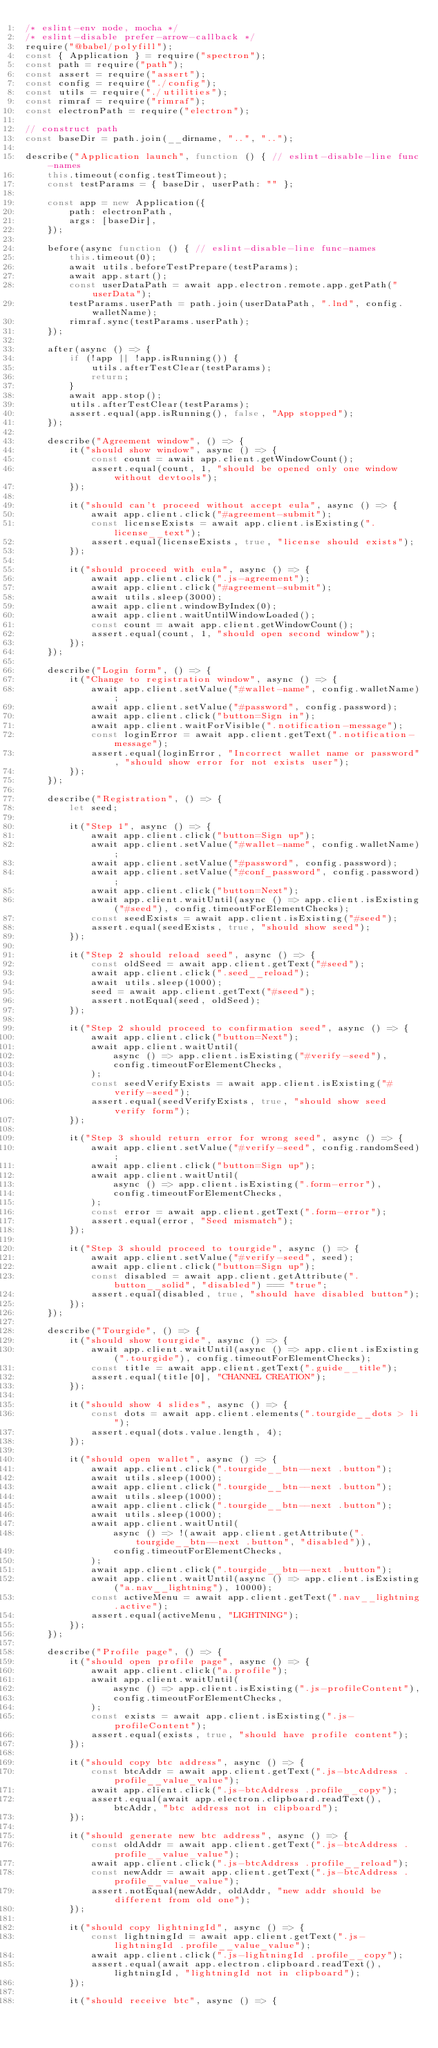<code> <loc_0><loc_0><loc_500><loc_500><_JavaScript_>/* eslint-env node, mocha */
/* eslint-disable prefer-arrow-callback */
require("@babel/polyfill");
const { Application } = require("spectron");
const path = require("path");
const assert = require("assert");
const config = require("./config");
const utils = require("./utilities");
const rimraf = require("rimraf");
const electronPath = require("electron");

// construct path
const baseDir = path.join(__dirname, "..", "..");

describe("Application launch", function () { // eslint-disable-line func-names
    this.timeout(config.testTimeout);
    const testParams = { baseDir, userPath: "" };

    const app = new Application({
        path: electronPath,
        args: [baseDir],
    });

    before(async function () { // eslint-disable-line func-names
        this.timeout(0);
        await utils.beforeTestPrepare(testParams);
        await app.start();
        const userDataPath = await app.electron.remote.app.getPath("userData");
        testParams.userPath = path.join(userDataPath, ".lnd", config.walletName);
        rimraf.sync(testParams.userPath);
    });

    after(async () => {
        if (!app || !app.isRunning()) {
            utils.afterTestClear(testParams);
            return;
        }
        await app.stop();
        utils.afterTestClear(testParams);
        assert.equal(app.isRunning(), false, "App stopped");
    });

    describe("Agreement window", () => {
        it("should show window", async () => {
            const count = await app.client.getWindowCount();
            assert.equal(count, 1, "should be opened only one window without devtools");
        });

        it("should can't proceed without accept eula", async () => {
            await app.client.click("#agreement-submit");
            const licenseExists = await app.client.isExisting(".license__text");
            assert.equal(licenseExists, true, "license should exists");
        });

        it("should proceed with eula", async () => {
            await app.client.click(".js-agreement");
            await app.client.click("#agreement-submit");
            await utils.sleep(3000);
            await app.client.windowByIndex(0);
            await app.client.waitUntilWindowLoaded();
            const count = await app.client.getWindowCount();
            assert.equal(count, 1, "should open second window");
        });
    });

    describe("Login form", () => {
        it("Change to registration window", async () => {
            await app.client.setValue("#wallet-name", config.walletName);
            await app.client.setValue("#password", config.password);
            await app.client.click("button=Sign in");
            await app.client.waitForVisible(".notification-message");
            const loginError = await app.client.getText(".notification-message");
            assert.equal(loginError, "Incorrect wallet name or password", "should show error for not exists user");
        });
    });

    describe("Registration", () => {
        let seed;

        it("Step 1", async () => {
            await app.client.click("button=Sign up");
            await app.client.setValue("#wallet-name", config.walletName);
            await app.client.setValue("#password", config.password);
            await app.client.setValue("#conf_password", config.password);
            await app.client.click("button=Next");
            await app.client.waitUntil(async () => app.client.isExisting("#seed"), config.timeoutForElementChecks);
            const seedExists = await app.client.isExisting("#seed");
            assert.equal(seedExists, true, "should show seed");
        });

        it("Step 2 should reload seed", async () => {
            const oldSeed = await app.client.getText("#seed");
            await app.client.click(".seed__reload");
            await utils.sleep(1000);
            seed = await app.client.getText("#seed");
            assert.notEqual(seed, oldSeed);
        });

        it("Step 2 should proceed to confirmation seed", async () => {
            await app.client.click("button=Next");
            await app.client.waitUntil(
                async () => app.client.isExisting("#verify-seed"),
                config.timeoutForElementChecks,
            );
            const seedVerifyExists = await app.client.isExisting("#verify-seed");
            assert.equal(seedVerifyExists, true, "should show seed verify form");
        });

        it("Step 3 should return error for wrong seed", async () => {
            await app.client.setValue("#verify-seed", config.randomSeed);
            await app.client.click("button=Sign up");
            await app.client.waitUntil(
                async () => app.client.isExisting(".form-error"),
                config.timeoutForElementChecks,
            );
            const error = await app.client.getText(".form-error");
            assert.equal(error, "Seed mismatch");
        });

        it("Step 3 should proceed to tourgide", async () => {
            await app.client.setValue("#verify-seed", seed);
            await app.client.click("button=Sign up");
            const disabled = await app.client.getAttribute(".button__solid", "disabled") === "true";
            assert.equal(disabled, true, "should have disabled button");
        });
    });

    describe("Tourgide", () => {
        it("should show tourgide", async () => {
            await app.client.waitUntil(async () => app.client.isExisting(".tourgide"), config.timeoutForElementChecks);
            const title = await app.client.getText(".guide__title");
            assert.equal(title[0], "CHANNEL CREATION");
        });

        it("should show 4 slides", async () => {
            const dots = await app.client.elements(".tourgide__dots > li");
            assert.equal(dots.value.length, 4);
        });

        it("should open wallet", async () => {
            await app.client.click(".tourgide__btn--next .button");
            await utils.sleep(1000);
            await app.client.click(".tourgide__btn--next .button");
            await utils.sleep(1000);
            await app.client.click(".tourgide__btn--next .button");
            await utils.sleep(1000);
            await app.client.waitUntil(
                async () => !(await app.client.getAttribute(".tourgide__btn--next .button", "disabled")),
                config.timeoutForElementChecks,
            );
            await app.client.click(".tourgide__btn--next .button");
            await app.client.waitUntil(async () => app.client.isExisting("a.nav__lightning"), 10000);
            const activeMenu = await app.client.getText(".nav__lightning.active");
            assert.equal(activeMenu, "LIGHTNING");
        });
    });

    describe("Profile page", () => {
        it("should open profile page", async () => {
            await app.client.click("a.profile");
            await app.client.waitUntil(
                async () => app.client.isExisting(".js-profileContent"),
                config.timeoutForElementChecks,
            );
            const exists = await app.client.isExisting(".js-profileContent");
            assert.equal(exists, true, "should have profile content");
        });

        it("should copy btc address", async () => {
            const btcAddr = await app.client.getText(".js-btcAddress .profile__value_value");
            await app.client.click(".js-btcAddress .profile__copy");
            assert.equal(await app.electron.clipboard.readText(), btcAddr, "btc address not in clipboard");
        });

        it("should generate new btc address", async () => {
            const oldAddr = await app.client.getText(".js-btcAddress .profile__value_value");
            await app.client.click(".js-btcAddress .profile__reload");
            const newAddr = await app.client.getText(".js-btcAddress .profile__value_value");
            assert.notEqual(newAddr, oldAddr, "new addr should be different from old one");
        });

        it("should copy lightningId", async () => {
            const lightningId = await app.client.getText(".js-lightningId .profile__value_value");
            await app.client.click(".js-lightningId .profile__copy");
            assert.equal(await app.electron.clipboard.readText(), lightningId, "lightningId not in clipboard");
        });

        it("should receive btc", async () => {</code> 